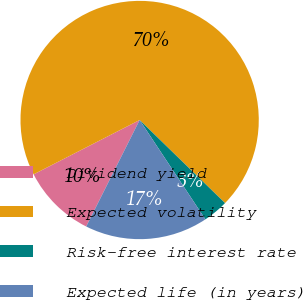<chart> <loc_0><loc_0><loc_500><loc_500><pie_chart><fcel>Dividend yield<fcel>Expected volatility<fcel>Risk-free interest rate<fcel>Expected life (in years)<nl><fcel>10.06%<fcel>69.82%<fcel>3.41%<fcel>16.71%<nl></chart> 